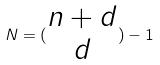<formula> <loc_0><loc_0><loc_500><loc_500>N = ( \begin{matrix} n + d \\ d \end{matrix} ) - 1</formula> 